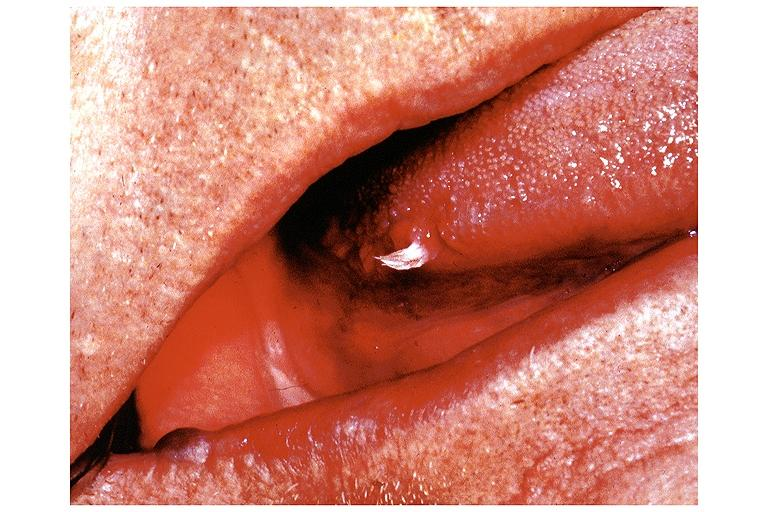what is present?
Answer the question using a single word or phrase. Oral 